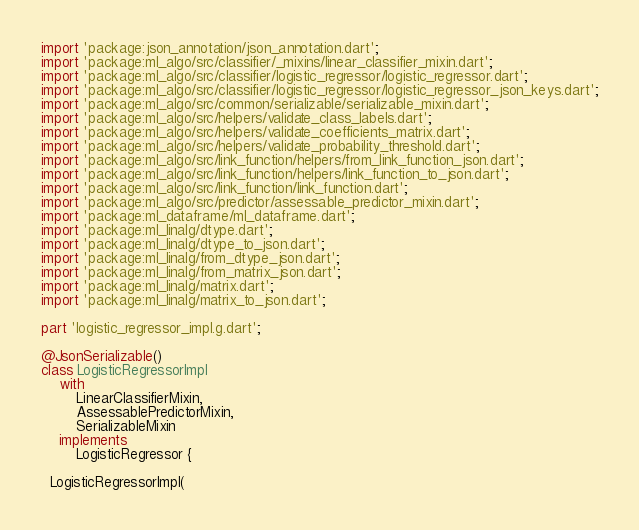<code> <loc_0><loc_0><loc_500><loc_500><_Dart_>import 'package:json_annotation/json_annotation.dart';
import 'package:ml_algo/src/classifier/_mixins/linear_classifier_mixin.dart';
import 'package:ml_algo/src/classifier/logistic_regressor/logistic_regressor.dart';
import 'package:ml_algo/src/classifier/logistic_regressor/logistic_regressor_json_keys.dart';
import 'package:ml_algo/src/common/serializable/serializable_mixin.dart';
import 'package:ml_algo/src/helpers/validate_class_labels.dart';
import 'package:ml_algo/src/helpers/validate_coefficients_matrix.dart';
import 'package:ml_algo/src/helpers/validate_probability_threshold.dart';
import 'package:ml_algo/src/link_function/helpers/from_link_function_json.dart';
import 'package:ml_algo/src/link_function/helpers/link_function_to_json.dart';
import 'package:ml_algo/src/link_function/link_function.dart';
import 'package:ml_algo/src/predictor/assessable_predictor_mixin.dart';
import 'package:ml_dataframe/ml_dataframe.dart';
import 'package:ml_linalg/dtype.dart';
import 'package:ml_linalg/dtype_to_json.dart';
import 'package:ml_linalg/from_dtype_json.dart';
import 'package:ml_linalg/from_matrix_json.dart';
import 'package:ml_linalg/matrix.dart';
import 'package:ml_linalg/matrix_to_json.dart';

part 'logistic_regressor_impl.g.dart';

@JsonSerializable()
class LogisticRegressorImpl
    with
        LinearClassifierMixin,
        AssessablePredictorMixin,
        SerializableMixin
    implements
        LogisticRegressor {

  LogisticRegressorImpl(</code> 